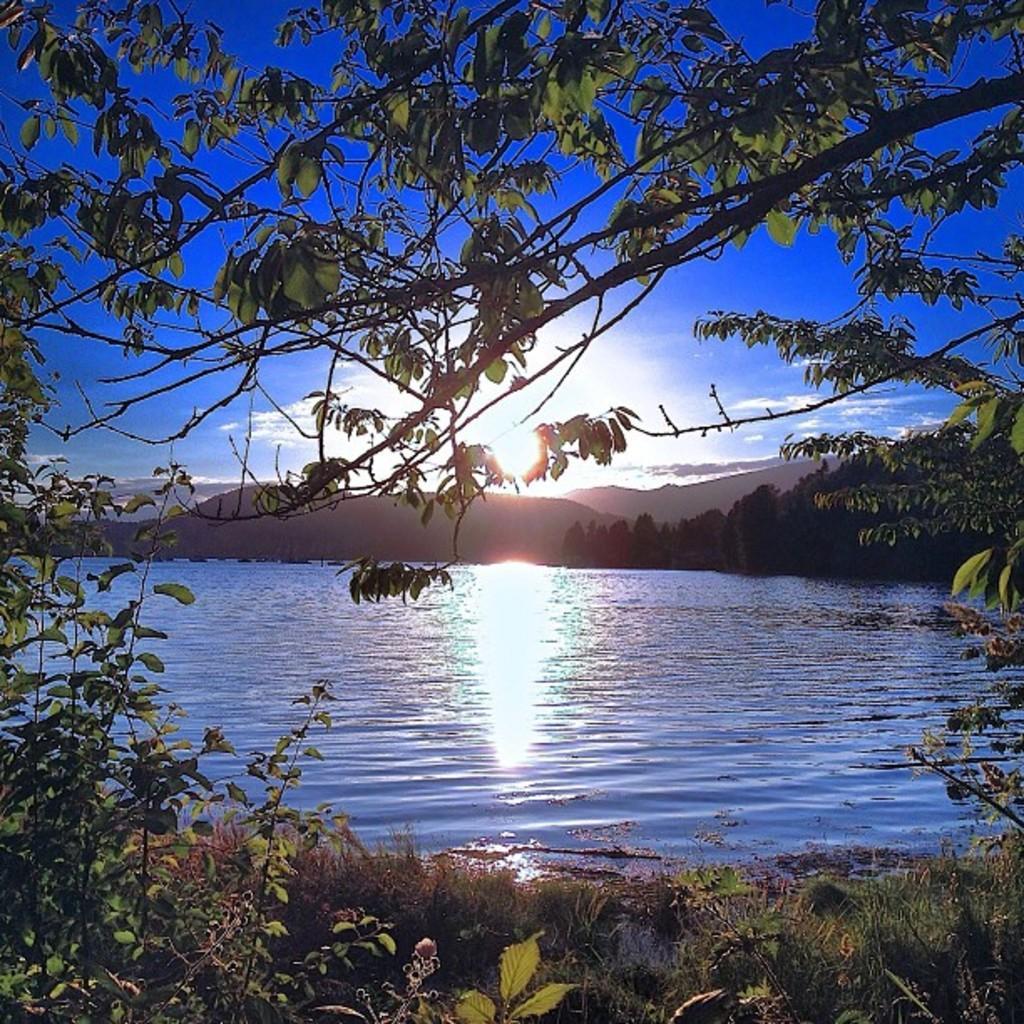Describe this image in one or two sentences. In this image we can see trees, there is the water, there are mountains, there is sun in the sky. 